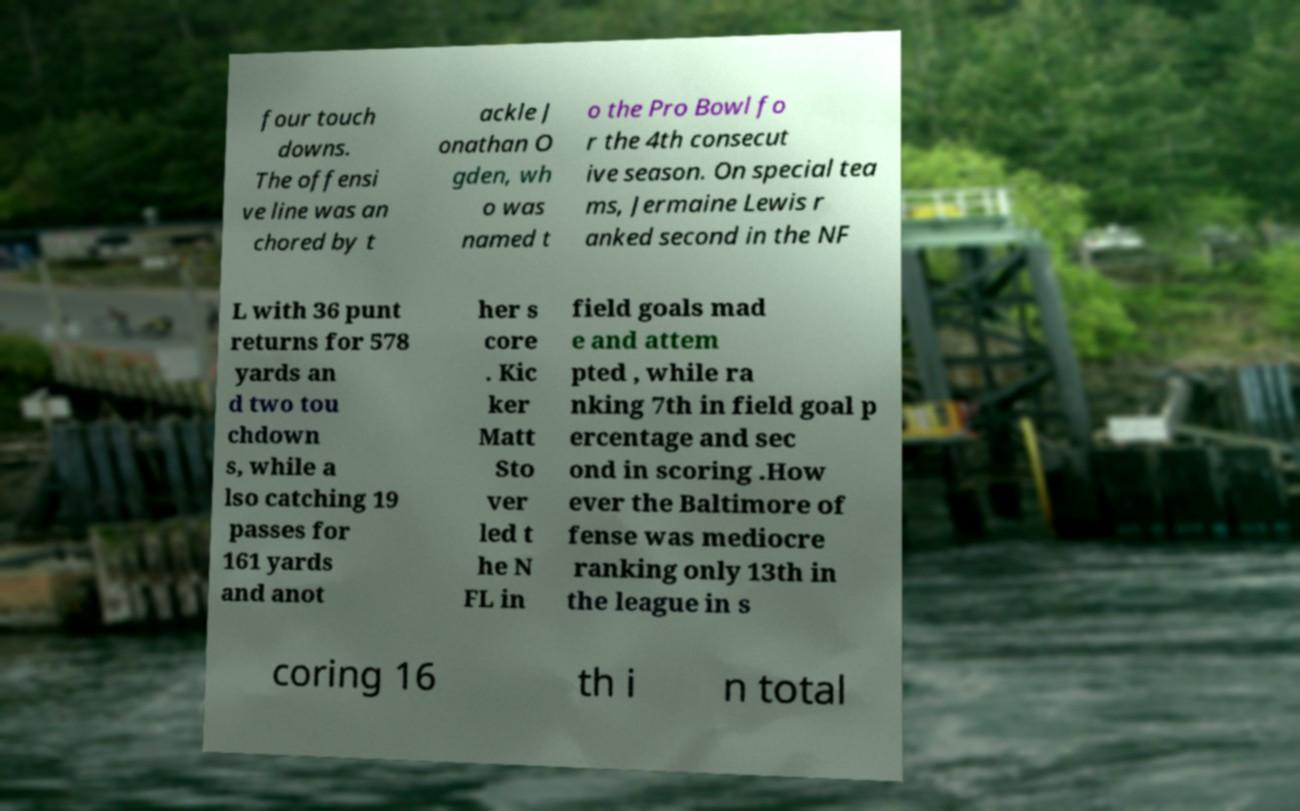Can you accurately transcribe the text from the provided image for me? four touch downs. The offensi ve line was an chored by t ackle J onathan O gden, wh o was named t o the Pro Bowl fo r the 4th consecut ive season. On special tea ms, Jermaine Lewis r anked second in the NF L with 36 punt returns for 578 yards an d two tou chdown s, while a lso catching 19 passes for 161 yards and anot her s core . Kic ker Matt Sto ver led t he N FL in field goals mad e and attem pted , while ra nking 7th in field goal p ercentage and sec ond in scoring .How ever the Baltimore of fense was mediocre ranking only 13th in the league in s coring 16 th i n total 